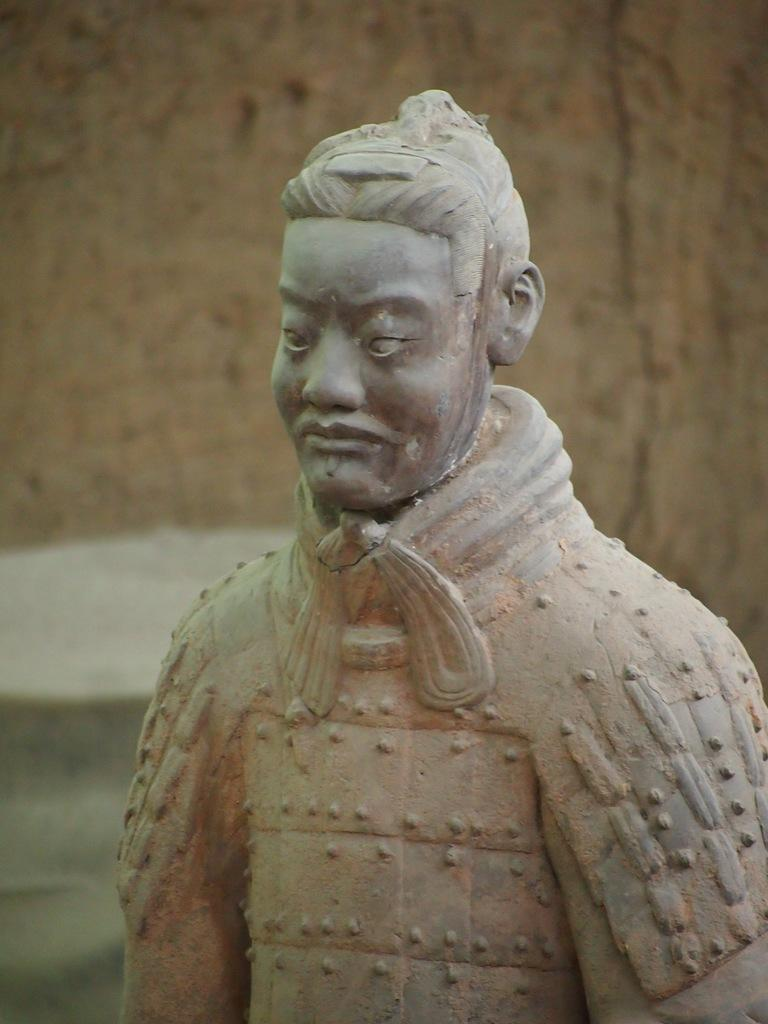What is the main subject of the image? There is a statue in the image. Can you describe the statue? The statue is of a person. What type of rhythm does the spy use to enter the store in the image? There is no spy or store present in the image; it features a statue of a person. 